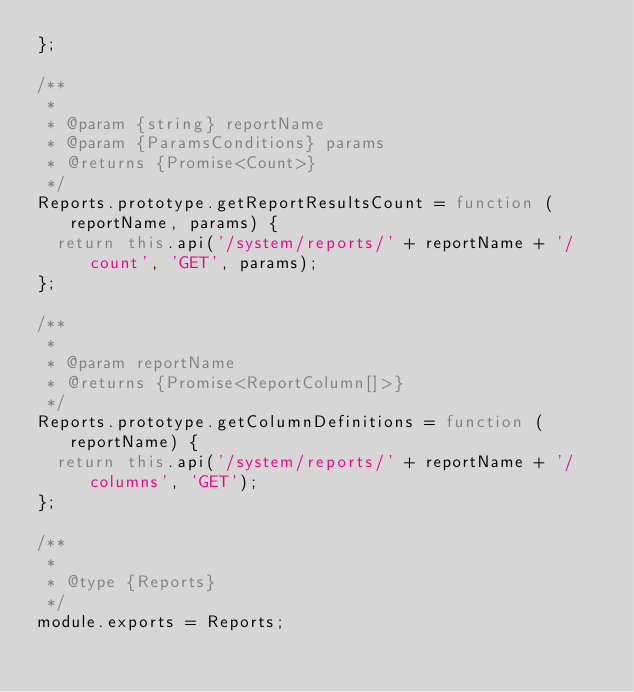Convert code to text. <code><loc_0><loc_0><loc_500><loc_500><_JavaScript_>};

/**
 *
 * @param {string} reportName
 * @param {ParamsConditions} params
 * @returns {Promise<Count>}
 */
Reports.prototype.getReportResultsCount = function (reportName, params) {
  return this.api('/system/reports/' + reportName + '/count', 'GET', params);
};

/**
 *
 * @param reportName
 * @returns {Promise<ReportColumn[]>}
 */
Reports.prototype.getColumnDefinitions = function (reportName) {
  return this.api('/system/reports/' + reportName + '/columns', 'GET');
};

/**
 *
 * @type {Reports}
 */
module.exports = Reports;
</code> 